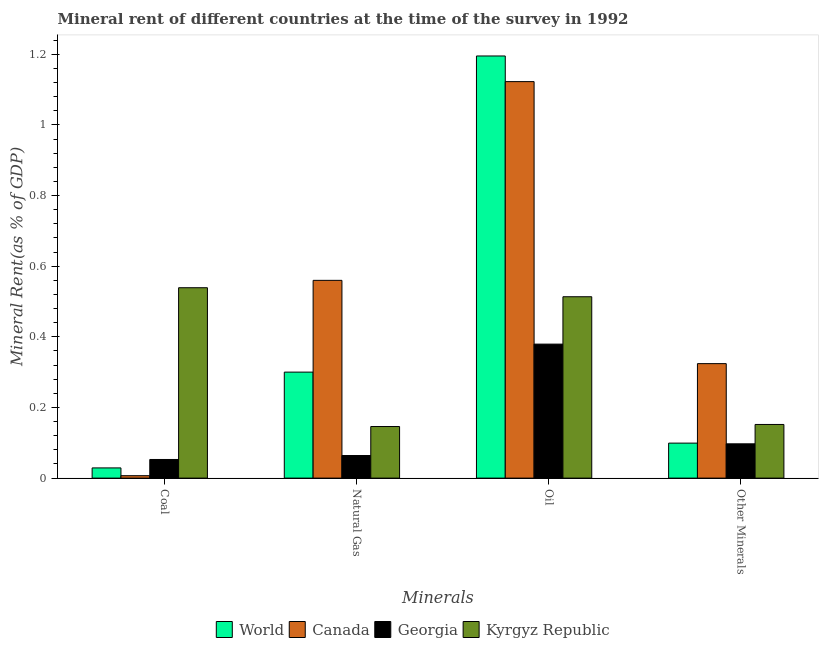How many different coloured bars are there?
Make the answer very short. 4. How many groups of bars are there?
Your response must be concise. 4. Are the number of bars per tick equal to the number of legend labels?
Offer a very short reply. Yes. How many bars are there on the 4th tick from the right?
Make the answer very short. 4. What is the label of the 4th group of bars from the left?
Your answer should be compact. Other Minerals. What is the natural gas rent in Georgia?
Your answer should be compact. 0.06. Across all countries, what is the maximum coal rent?
Provide a succinct answer. 0.54. Across all countries, what is the minimum coal rent?
Provide a short and direct response. 0.01. In which country was the  rent of other minerals maximum?
Offer a very short reply. Canada. In which country was the natural gas rent minimum?
Ensure brevity in your answer.  Georgia. What is the total coal rent in the graph?
Provide a succinct answer. 0.63. What is the difference between the oil rent in Georgia and that in Kyrgyz Republic?
Ensure brevity in your answer.  -0.13. What is the difference between the oil rent in Georgia and the  rent of other minerals in World?
Your answer should be very brief. 0.28. What is the average coal rent per country?
Your response must be concise. 0.16. What is the difference between the natural gas rent and oil rent in Canada?
Ensure brevity in your answer.  -0.56. What is the ratio of the oil rent in Canada to that in World?
Provide a succinct answer. 0.94. What is the difference between the highest and the second highest natural gas rent?
Provide a short and direct response. 0.26. What is the difference between the highest and the lowest coal rent?
Your answer should be compact. 0.53. What does the 1st bar from the left in Oil represents?
Provide a succinct answer. World. What does the 1st bar from the right in Other Minerals represents?
Ensure brevity in your answer.  Kyrgyz Republic. Are all the bars in the graph horizontal?
Your answer should be compact. No. How many countries are there in the graph?
Offer a terse response. 4. Are the values on the major ticks of Y-axis written in scientific E-notation?
Offer a very short reply. No. Does the graph contain any zero values?
Your answer should be very brief. No. Where does the legend appear in the graph?
Ensure brevity in your answer.  Bottom center. How many legend labels are there?
Offer a very short reply. 4. How are the legend labels stacked?
Provide a short and direct response. Horizontal. What is the title of the graph?
Give a very brief answer. Mineral rent of different countries at the time of the survey in 1992. Does "Isle of Man" appear as one of the legend labels in the graph?
Offer a very short reply. No. What is the label or title of the X-axis?
Offer a very short reply. Minerals. What is the label or title of the Y-axis?
Ensure brevity in your answer.  Mineral Rent(as % of GDP). What is the Mineral Rent(as % of GDP) in World in Coal?
Provide a succinct answer. 0.03. What is the Mineral Rent(as % of GDP) of Canada in Coal?
Your response must be concise. 0.01. What is the Mineral Rent(as % of GDP) in Georgia in Coal?
Provide a succinct answer. 0.05. What is the Mineral Rent(as % of GDP) of Kyrgyz Republic in Coal?
Your answer should be compact. 0.54. What is the Mineral Rent(as % of GDP) of World in Natural Gas?
Keep it short and to the point. 0.3. What is the Mineral Rent(as % of GDP) in Canada in Natural Gas?
Provide a succinct answer. 0.56. What is the Mineral Rent(as % of GDP) of Georgia in Natural Gas?
Provide a succinct answer. 0.06. What is the Mineral Rent(as % of GDP) of Kyrgyz Republic in Natural Gas?
Keep it short and to the point. 0.15. What is the Mineral Rent(as % of GDP) of World in Oil?
Your response must be concise. 1.2. What is the Mineral Rent(as % of GDP) of Canada in Oil?
Make the answer very short. 1.12. What is the Mineral Rent(as % of GDP) of Georgia in Oil?
Your answer should be very brief. 0.38. What is the Mineral Rent(as % of GDP) in Kyrgyz Republic in Oil?
Provide a succinct answer. 0.51. What is the Mineral Rent(as % of GDP) in World in Other Minerals?
Your response must be concise. 0.1. What is the Mineral Rent(as % of GDP) in Canada in Other Minerals?
Ensure brevity in your answer.  0.32. What is the Mineral Rent(as % of GDP) of Georgia in Other Minerals?
Your response must be concise. 0.1. What is the Mineral Rent(as % of GDP) of Kyrgyz Republic in Other Minerals?
Offer a very short reply. 0.15. Across all Minerals, what is the maximum Mineral Rent(as % of GDP) in World?
Give a very brief answer. 1.2. Across all Minerals, what is the maximum Mineral Rent(as % of GDP) of Canada?
Your answer should be very brief. 1.12. Across all Minerals, what is the maximum Mineral Rent(as % of GDP) in Georgia?
Make the answer very short. 0.38. Across all Minerals, what is the maximum Mineral Rent(as % of GDP) of Kyrgyz Republic?
Give a very brief answer. 0.54. Across all Minerals, what is the minimum Mineral Rent(as % of GDP) of World?
Your response must be concise. 0.03. Across all Minerals, what is the minimum Mineral Rent(as % of GDP) of Canada?
Your response must be concise. 0.01. Across all Minerals, what is the minimum Mineral Rent(as % of GDP) of Georgia?
Your answer should be very brief. 0.05. Across all Minerals, what is the minimum Mineral Rent(as % of GDP) in Kyrgyz Republic?
Offer a terse response. 0.15. What is the total Mineral Rent(as % of GDP) in World in the graph?
Provide a succinct answer. 1.62. What is the total Mineral Rent(as % of GDP) of Canada in the graph?
Give a very brief answer. 2.01. What is the total Mineral Rent(as % of GDP) of Georgia in the graph?
Keep it short and to the point. 0.59. What is the total Mineral Rent(as % of GDP) of Kyrgyz Republic in the graph?
Ensure brevity in your answer.  1.35. What is the difference between the Mineral Rent(as % of GDP) in World in Coal and that in Natural Gas?
Provide a short and direct response. -0.27. What is the difference between the Mineral Rent(as % of GDP) in Canada in Coal and that in Natural Gas?
Provide a short and direct response. -0.55. What is the difference between the Mineral Rent(as % of GDP) of Georgia in Coal and that in Natural Gas?
Offer a very short reply. -0.01. What is the difference between the Mineral Rent(as % of GDP) in Kyrgyz Republic in Coal and that in Natural Gas?
Ensure brevity in your answer.  0.39. What is the difference between the Mineral Rent(as % of GDP) of World in Coal and that in Oil?
Offer a terse response. -1.17. What is the difference between the Mineral Rent(as % of GDP) of Canada in Coal and that in Oil?
Keep it short and to the point. -1.12. What is the difference between the Mineral Rent(as % of GDP) of Georgia in Coal and that in Oil?
Offer a very short reply. -0.33. What is the difference between the Mineral Rent(as % of GDP) in Kyrgyz Republic in Coal and that in Oil?
Your answer should be very brief. 0.03. What is the difference between the Mineral Rent(as % of GDP) in World in Coal and that in Other Minerals?
Provide a short and direct response. -0.07. What is the difference between the Mineral Rent(as % of GDP) in Canada in Coal and that in Other Minerals?
Provide a short and direct response. -0.32. What is the difference between the Mineral Rent(as % of GDP) of Georgia in Coal and that in Other Minerals?
Provide a short and direct response. -0.04. What is the difference between the Mineral Rent(as % of GDP) of Kyrgyz Republic in Coal and that in Other Minerals?
Give a very brief answer. 0.39. What is the difference between the Mineral Rent(as % of GDP) of World in Natural Gas and that in Oil?
Offer a very short reply. -0.9. What is the difference between the Mineral Rent(as % of GDP) of Canada in Natural Gas and that in Oil?
Your answer should be very brief. -0.56. What is the difference between the Mineral Rent(as % of GDP) of Georgia in Natural Gas and that in Oil?
Provide a short and direct response. -0.32. What is the difference between the Mineral Rent(as % of GDP) in Kyrgyz Republic in Natural Gas and that in Oil?
Give a very brief answer. -0.37. What is the difference between the Mineral Rent(as % of GDP) of World in Natural Gas and that in Other Minerals?
Your answer should be very brief. 0.2. What is the difference between the Mineral Rent(as % of GDP) in Canada in Natural Gas and that in Other Minerals?
Your answer should be very brief. 0.24. What is the difference between the Mineral Rent(as % of GDP) in Georgia in Natural Gas and that in Other Minerals?
Make the answer very short. -0.03. What is the difference between the Mineral Rent(as % of GDP) in Kyrgyz Republic in Natural Gas and that in Other Minerals?
Ensure brevity in your answer.  -0.01. What is the difference between the Mineral Rent(as % of GDP) of World in Oil and that in Other Minerals?
Ensure brevity in your answer.  1.1. What is the difference between the Mineral Rent(as % of GDP) of Canada in Oil and that in Other Minerals?
Offer a very short reply. 0.8. What is the difference between the Mineral Rent(as % of GDP) of Georgia in Oil and that in Other Minerals?
Make the answer very short. 0.28. What is the difference between the Mineral Rent(as % of GDP) in Kyrgyz Republic in Oil and that in Other Minerals?
Your answer should be compact. 0.36. What is the difference between the Mineral Rent(as % of GDP) in World in Coal and the Mineral Rent(as % of GDP) in Canada in Natural Gas?
Give a very brief answer. -0.53. What is the difference between the Mineral Rent(as % of GDP) of World in Coal and the Mineral Rent(as % of GDP) of Georgia in Natural Gas?
Provide a short and direct response. -0.04. What is the difference between the Mineral Rent(as % of GDP) of World in Coal and the Mineral Rent(as % of GDP) of Kyrgyz Republic in Natural Gas?
Offer a very short reply. -0.12. What is the difference between the Mineral Rent(as % of GDP) of Canada in Coal and the Mineral Rent(as % of GDP) of Georgia in Natural Gas?
Your answer should be very brief. -0.06. What is the difference between the Mineral Rent(as % of GDP) in Canada in Coal and the Mineral Rent(as % of GDP) in Kyrgyz Republic in Natural Gas?
Provide a succinct answer. -0.14. What is the difference between the Mineral Rent(as % of GDP) of Georgia in Coal and the Mineral Rent(as % of GDP) of Kyrgyz Republic in Natural Gas?
Offer a very short reply. -0.09. What is the difference between the Mineral Rent(as % of GDP) of World in Coal and the Mineral Rent(as % of GDP) of Canada in Oil?
Provide a succinct answer. -1.09. What is the difference between the Mineral Rent(as % of GDP) in World in Coal and the Mineral Rent(as % of GDP) in Georgia in Oil?
Provide a succinct answer. -0.35. What is the difference between the Mineral Rent(as % of GDP) in World in Coal and the Mineral Rent(as % of GDP) in Kyrgyz Republic in Oil?
Keep it short and to the point. -0.48. What is the difference between the Mineral Rent(as % of GDP) in Canada in Coal and the Mineral Rent(as % of GDP) in Georgia in Oil?
Give a very brief answer. -0.37. What is the difference between the Mineral Rent(as % of GDP) in Canada in Coal and the Mineral Rent(as % of GDP) in Kyrgyz Republic in Oil?
Keep it short and to the point. -0.51. What is the difference between the Mineral Rent(as % of GDP) of Georgia in Coal and the Mineral Rent(as % of GDP) of Kyrgyz Republic in Oil?
Keep it short and to the point. -0.46. What is the difference between the Mineral Rent(as % of GDP) of World in Coal and the Mineral Rent(as % of GDP) of Canada in Other Minerals?
Give a very brief answer. -0.3. What is the difference between the Mineral Rent(as % of GDP) of World in Coal and the Mineral Rent(as % of GDP) of Georgia in Other Minerals?
Offer a very short reply. -0.07. What is the difference between the Mineral Rent(as % of GDP) in World in Coal and the Mineral Rent(as % of GDP) in Kyrgyz Republic in Other Minerals?
Offer a very short reply. -0.12. What is the difference between the Mineral Rent(as % of GDP) of Canada in Coal and the Mineral Rent(as % of GDP) of Georgia in Other Minerals?
Your response must be concise. -0.09. What is the difference between the Mineral Rent(as % of GDP) of Canada in Coal and the Mineral Rent(as % of GDP) of Kyrgyz Republic in Other Minerals?
Offer a very short reply. -0.15. What is the difference between the Mineral Rent(as % of GDP) of Georgia in Coal and the Mineral Rent(as % of GDP) of Kyrgyz Republic in Other Minerals?
Offer a very short reply. -0.1. What is the difference between the Mineral Rent(as % of GDP) in World in Natural Gas and the Mineral Rent(as % of GDP) in Canada in Oil?
Offer a terse response. -0.82. What is the difference between the Mineral Rent(as % of GDP) in World in Natural Gas and the Mineral Rent(as % of GDP) in Georgia in Oil?
Keep it short and to the point. -0.08. What is the difference between the Mineral Rent(as % of GDP) in World in Natural Gas and the Mineral Rent(as % of GDP) in Kyrgyz Republic in Oil?
Make the answer very short. -0.21. What is the difference between the Mineral Rent(as % of GDP) in Canada in Natural Gas and the Mineral Rent(as % of GDP) in Georgia in Oil?
Your answer should be very brief. 0.18. What is the difference between the Mineral Rent(as % of GDP) of Canada in Natural Gas and the Mineral Rent(as % of GDP) of Kyrgyz Republic in Oil?
Provide a succinct answer. 0.05. What is the difference between the Mineral Rent(as % of GDP) in Georgia in Natural Gas and the Mineral Rent(as % of GDP) in Kyrgyz Republic in Oil?
Provide a succinct answer. -0.45. What is the difference between the Mineral Rent(as % of GDP) in World in Natural Gas and the Mineral Rent(as % of GDP) in Canada in Other Minerals?
Your answer should be very brief. -0.02. What is the difference between the Mineral Rent(as % of GDP) in World in Natural Gas and the Mineral Rent(as % of GDP) in Georgia in Other Minerals?
Your response must be concise. 0.2. What is the difference between the Mineral Rent(as % of GDP) of World in Natural Gas and the Mineral Rent(as % of GDP) of Kyrgyz Republic in Other Minerals?
Ensure brevity in your answer.  0.15. What is the difference between the Mineral Rent(as % of GDP) in Canada in Natural Gas and the Mineral Rent(as % of GDP) in Georgia in Other Minerals?
Your response must be concise. 0.46. What is the difference between the Mineral Rent(as % of GDP) in Canada in Natural Gas and the Mineral Rent(as % of GDP) in Kyrgyz Republic in Other Minerals?
Provide a succinct answer. 0.41. What is the difference between the Mineral Rent(as % of GDP) in Georgia in Natural Gas and the Mineral Rent(as % of GDP) in Kyrgyz Republic in Other Minerals?
Your answer should be very brief. -0.09. What is the difference between the Mineral Rent(as % of GDP) of World in Oil and the Mineral Rent(as % of GDP) of Canada in Other Minerals?
Your answer should be very brief. 0.87. What is the difference between the Mineral Rent(as % of GDP) in World in Oil and the Mineral Rent(as % of GDP) in Georgia in Other Minerals?
Ensure brevity in your answer.  1.1. What is the difference between the Mineral Rent(as % of GDP) in World in Oil and the Mineral Rent(as % of GDP) in Kyrgyz Republic in Other Minerals?
Offer a terse response. 1.04. What is the difference between the Mineral Rent(as % of GDP) in Canada in Oil and the Mineral Rent(as % of GDP) in Georgia in Other Minerals?
Make the answer very short. 1.03. What is the difference between the Mineral Rent(as % of GDP) of Canada in Oil and the Mineral Rent(as % of GDP) of Kyrgyz Republic in Other Minerals?
Ensure brevity in your answer.  0.97. What is the difference between the Mineral Rent(as % of GDP) of Georgia in Oil and the Mineral Rent(as % of GDP) of Kyrgyz Republic in Other Minerals?
Your answer should be compact. 0.23. What is the average Mineral Rent(as % of GDP) of World per Minerals?
Keep it short and to the point. 0.41. What is the average Mineral Rent(as % of GDP) of Canada per Minerals?
Your answer should be very brief. 0.5. What is the average Mineral Rent(as % of GDP) in Georgia per Minerals?
Your answer should be compact. 0.15. What is the average Mineral Rent(as % of GDP) in Kyrgyz Republic per Minerals?
Provide a succinct answer. 0.34. What is the difference between the Mineral Rent(as % of GDP) in World and Mineral Rent(as % of GDP) in Canada in Coal?
Keep it short and to the point. 0.02. What is the difference between the Mineral Rent(as % of GDP) in World and Mineral Rent(as % of GDP) in Georgia in Coal?
Make the answer very short. -0.02. What is the difference between the Mineral Rent(as % of GDP) of World and Mineral Rent(as % of GDP) of Kyrgyz Republic in Coal?
Your response must be concise. -0.51. What is the difference between the Mineral Rent(as % of GDP) in Canada and Mineral Rent(as % of GDP) in Georgia in Coal?
Make the answer very short. -0.05. What is the difference between the Mineral Rent(as % of GDP) in Canada and Mineral Rent(as % of GDP) in Kyrgyz Republic in Coal?
Give a very brief answer. -0.53. What is the difference between the Mineral Rent(as % of GDP) of Georgia and Mineral Rent(as % of GDP) of Kyrgyz Republic in Coal?
Offer a very short reply. -0.49. What is the difference between the Mineral Rent(as % of GDP) of World and Mineral Rent(as % of GDP) of Canada in Natural Gas?
Your answer should be very brief. -0.26. What is the difference between the Mineral Rent(as % of GDP) of World and Mineral Rent(as % of GDP) of Georgia in Natural Gas?
Offer a very short reply. 0.24. What is the difference between the Mineral Rent(as % of GDP) of World and Mineral Rent(as % of GDP) of Kyrgyz Republic in Natural Gas?
Offer a terse response. 0.15. What is the difference between the Mineral Rent(as % of GDP) of Canada and Mineral Rent(as % of GDP) of Georgia in Natural Gas?
Provide a succinct answer. 0.5. What is the difference between the Mineral Rent(as % of GDP) of Canada and Mineral Rent(as % of GDP) of Kyrgyz Republic in Natural Gas?
Your response must be concise. 0.41. What is the difference between the Mineral Rent(as % of GDP) of Georgia and Mineral Rent(as % of GDP) of Kyrgyz Republic in Natural Gas?
Offer a terse response. -0.08. What is the difference between the Mineral Rent(as % of GDP) in World and Mineral Rent(as % of GDP) in Canada in Oil?
Offer a very short reply. 0.07. What is the difference between the Mineral Rent(as % of GDP) in World and Mineral Rent(as % of GDP) in Georgia in Oil?
Your answer should be very brief. 0.82. What is the difference between the Mineral Rent(as % of GDP) of World and Mineral Rent(as % of GDP) of Kyrgyz Republic in Oil?
Offer a terse response. 0.68. What is the difference between the Mineral Rent(as % of GDP) in Canada and Mineral Rent(as % of GDP) in Georgia in Oil?
Give a very brief answer. 0.74. What is the difference between the Mineral Rent(as % of GDP) in Canada and Mineral Rent(as % of GDP) in Kyrgyz Republic in Oil?
Give a very brief answer. 0.61. What is the difference between the Mineral Rent(as % of GDP) of Georgia and Mineral Rent(as % of GDP) of Kyrgyz Republic in Oil?
Keep it short and to the point. -0.13. What is the difference between the Mineral Rent(as % of GDP) in World and Mineral Rent(as % of GDP) in Canada in Other Minerals?
Provide a succinct answer. -0.23. What is the difference between the Mineral Rent(as % of GDP) of World and Mineral Rent(as % of GDP) of Georgia in Other Minerals?
Provide a succinct answer. 0. What is the difference between the Mineral Rent(as % of GDP) of World and Mineral Rent(as % of GDP) of Kyrgyz Republic in Other Minerals?
Offer a terse response. -0.05. What is the difference between the Mineral Rent(as % of GDP) of Canada and Mineral Rent(as % of GDP) of Georgia in Other Minerals?
Your answer should be compact. 0.23. What is the difference between the Mineral Rent(as % of GDP) in Canada and Mineral Rent(as % of GDP) in Kyrgyz Republic in Other Minerals?
Your response must be concise. 0.17. What is the difference between the Mineral Rent(as % of GDP) of Georgia and Mineral Rent(as % of GDP) of Kyrgyz Republic in Other Minerals?
Make the answer very short. -0.05. What is the ratio of the Mineral Rent(as % of GDP) in World in Coal to that in Natural Gas?
Keep it short and to the point. 0.1. What is the ratio of the Mineral Rent(as % of GDP) of Canada in Coal to that in Natural Gas?
Your answer should be compact. 0.01. What is the ratio of the Mineral Rent(as % of GDP) in Georgia in Coal to that in Natural Gas?
Offer a very short reply. 0.82. What is the ratio of the Mineral Rent(as % of GDP) in Kyrgyz Republic in Coal to that in Natural Gas?
Provide a succinct answer. 3.69. What is the ratio of the Mineral Rent(as % of GDP) in World in Coal to that in Oil?
Give a very brief answer. 0.02. What is the ratio of the Mineral Rent(as % of GDP) in Canada in Coal to that in Oil?
Your answer should be very brief. 0.01. What is the ratio of the Mineral Rent(as % of GDP) in Georgia in Coal to that in Oil?
Make the answer very short. 0.14. What is the ratio of the Mineral Rent(as % of GDP) of Kyrgyz Republic in Coal to that in Oil?
Ensure brevity in your answer.  1.05. What is the ratio of the Mineral Rent(as % of GDP) in World in Coal to that in Other Minerals?
Provide a short and direct response. 0.29. What is the ratio of the Mineral Rent(as % of GDP) in Canada in Coal to that in Other Minerals?
Your response must be concise. 0.02. What is the ratio of the Mineral Rent(as % of GDP) in Georgia in Coal to that in Other Minerals?
Provide a short and direct response. 0.54. What is the ratio of the Mineral Rent(as % of GDP) in Kyrgyz Republic in Coal to that in Other Minerals?
Provide a short and direct response. 3.55. What is the ratio of the Mineral Rent(as % of GDP) in World in Natural Gas to that in Oil?
Ensure brevity in your answer.  0.25. What is the ratio of the Mineral Rent(as % of GDP) of Canada in Natural Gas to that in Oil?
Provide a short and direct response. 0.5. What is the ratio of the Mineral Rent(as % of GDP) of Georgia in Natural Gas to that in Oil?
Provide a short and direct response. 0.17. What is the ratio of the Mineral Rent(as % of GDP) in Kyrgyz Republic in Natural Gas to that in Oil?
Offer a terse response. 0.28. What is the ratio of the Mineral Rent(as % of GDP) of World in Natural Gas to that in Other Minerals?
Your answer should be compact. 3.03. What is the ratio of the Mineral Rent(as % of GDP) of Canada in Natural Gas to that in Other Minerals?
Provide a succinct answer. 1.73. What is the ratio of the Mineral Rent(as % of GDP) in Georgia in Natural Gas to that in Other Minerals?
Make the answer very short. 0.66. What is the ratio of the Mineral Rent(as % of GDP) of Kyrgyz Republic in Natural Gas to that in Other Minerals?
Keep it short and to the point. 0.96. What is the ratio of the Mineral Rent(as % of GDP) in World in Oil to that in Other Minerals?
Keep it short and to the point. 12.06. What is the ratio of the Mineral Rent(as % of GDP) of Canada in Oil to that in Other Minerals?
Keep it short and to the point. 3.46. What is the ratio of the Mineral Rent(as % of GDP) of Georgia in Oil to that in Other Minerals?
Offer a terse response. 3.91. What is the ratio of the Mineral Rent(as % of GDP) in Kyrgyz Republic in Oil to that in Other Minerals?
Give a very brief answer. 3.38. What is the difference between the highest and the second highest Mineral Rent(as % of GDP) of World?
Offer a terse response. 0.9. What is the difference between the highest and the second highest Mineral Rent(as % of GDP) of Canada?
Provide a short and direct response. 0.56. What is the difference between the highest and the second highest Mineral Rent(as % of GDP) of Georgia?
Offer a terse response. 0.28. What is the difference between the highest and the second highest Mineral Rent(as % of GDP) in Kyrgyz Republic?
Offer a very short reply. 0.03. What is the difference between the highest and the lowest Mineral Rent(as % of GDP) of World?
Your answer should be compact. 1.17. What is the difference between the highest and the lowest Mineral Rent(as % of GDP) of Canada?
Give a very brief answer. 1.12. What is the difference between the highest and the lowest Mineral Rent(as % of GDP) of Georgia?
Your answer should be very brief. 0.33. What is the difference between the highest and the lowest Mineral Rent(as % of GDP) in Kyrgyz Republic?
Your answer should be compact. 0.39. 